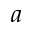<formula> <loc_0><loc_0><loc_500><loc_500>a</formula> 